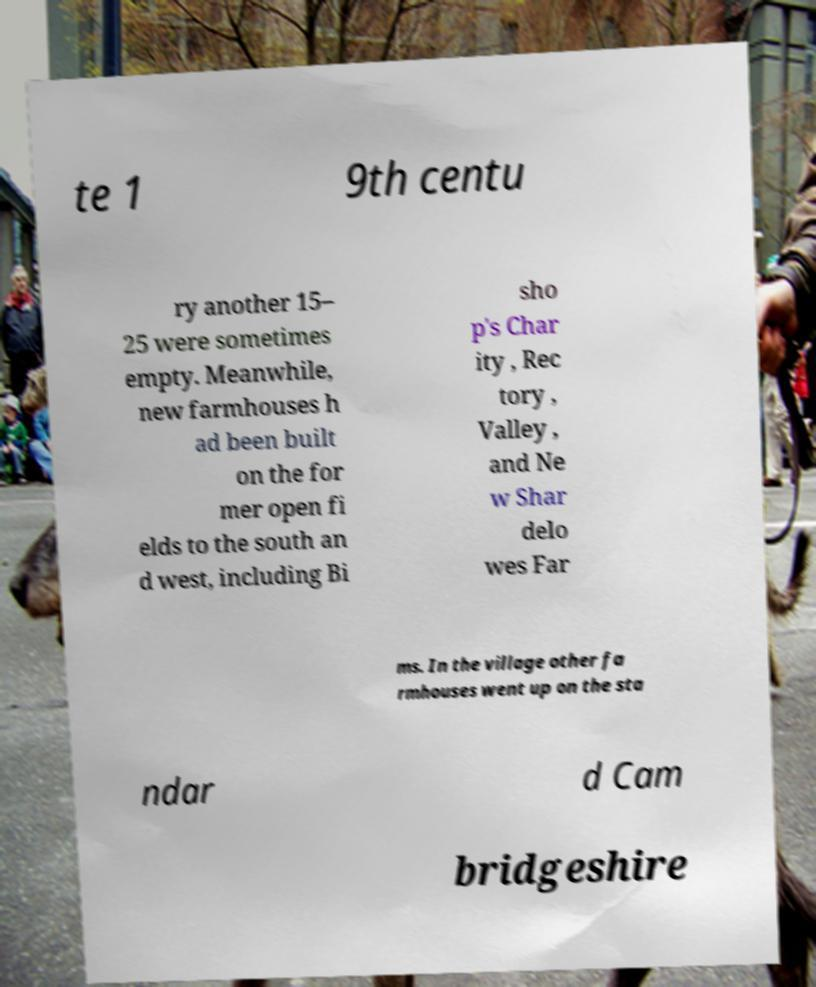For documentation purposes, I need the text within this image transcribed. Could you provide that? te 1 9th centu ry another 15– 25 were sometimes empty. Meanwhile, new farmhouses h ad been built on the for mer open fi elds to the south an d west, including Bi sho p's Char ity , Rec tory , Valley , and Ne w Shar delo wes Far ms. In the village other fa rmhouses went up on the sta ndar d Cam bridgeshire 